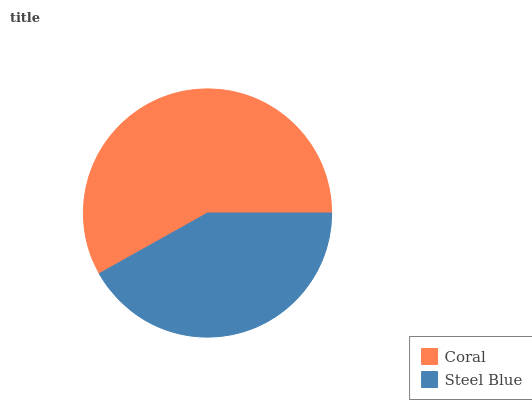Is Steel Blue the minimum?
Answer yes or no. Yes. Is Coral the maximum?
Answer yes or no. Yes. Is Steel Blue the maximum?
Answer yes or no. No. Is Coral greater than Steel Blue?
Answer yes or no. Yes. Is Steel Blue less than Coral?
Answer yes or no. Yes. Is Steel Blue greater than Coral?
Answer yes or no. No. Is Coral less than Steel Blue?
Answer yes or no. No. Is Coral the high median?
Answer yes or no. Yes. Is Steel Blue the low median?
Answer yes or no. Yes. Is Steel Blue the high median?
Answer yes or no. No. Is Coral the low median?
Answer yes or no. No. 